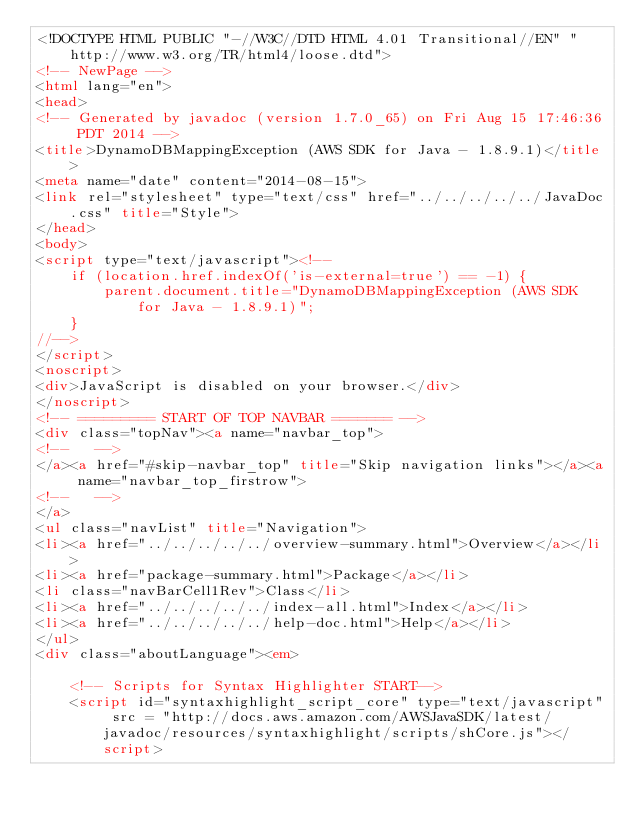<code> <loc_0><loc_0><loc_500><loc_500><_HTML_><!DOCTYPE HTML PUBLIC "-//W3C//DTD HTML 4.01 Transitional//EN" "http://www.w3.org/TR/html4/loose.dtd">
<!-- NewPage -->
<html lang="en">
<head>
<!-- Generated by javadoc (version 1.7.0_65) on Fri Aug 15 17:46:36 PDT 2014 -->
<title>DynamoDBMappingException (AWS SDK for Java - 1.8.9.1)</title>
<meta name="date" content="2014-08-15">
<link rel="stylesheet" type="text/css" href="../../../../../JavaDoc.css" title="Style">
</head>
<body>
<script type="text/javascript"><!--
    if (location.href.indexOf('is-external=true') == -1) {
        parent.document.title="DynamoDBMappingException (AWS SDK for Java - 1.8.9.1)";
    }
//-->
</script>
<noscript>
<div>JavaScript is disabled on your browser.</div>
</noscript>
<!-- ========= START OF TOP NAVBAR ======= -->
<div class="topNav"><a name="navbar_top">
<!--   -->
</a><a href="#skip-navbar_top" title="Skip navigation links"></a><a name="navbar_top_firstrow">
<!--   -->
</a>
<ul class="navList" title="Navigation">
<li><a href="../../../../../overview-summary.html">Overview</a></li>
<li><a href="package-summary.html">Package</a></li>
<li class="navBarCell1Rev">Class</li>
<li><a href="../../../../../index-all.html">Index</a></li>
<li><a href="../../../../../help-doc.html">Help</a></li>
</ul>
<div class="aboutLanguage"><em>

    <!-- Scripts for Syntax Highlighter START-->
    <script id="syntaxhighlight_script_core" type="text/javascript" src = "http://docs.aws.amazon.com/AWSJavaSDK/latest/javadoc/resources/syntaxhighlight/scripts/shCore.js"></script></code> 